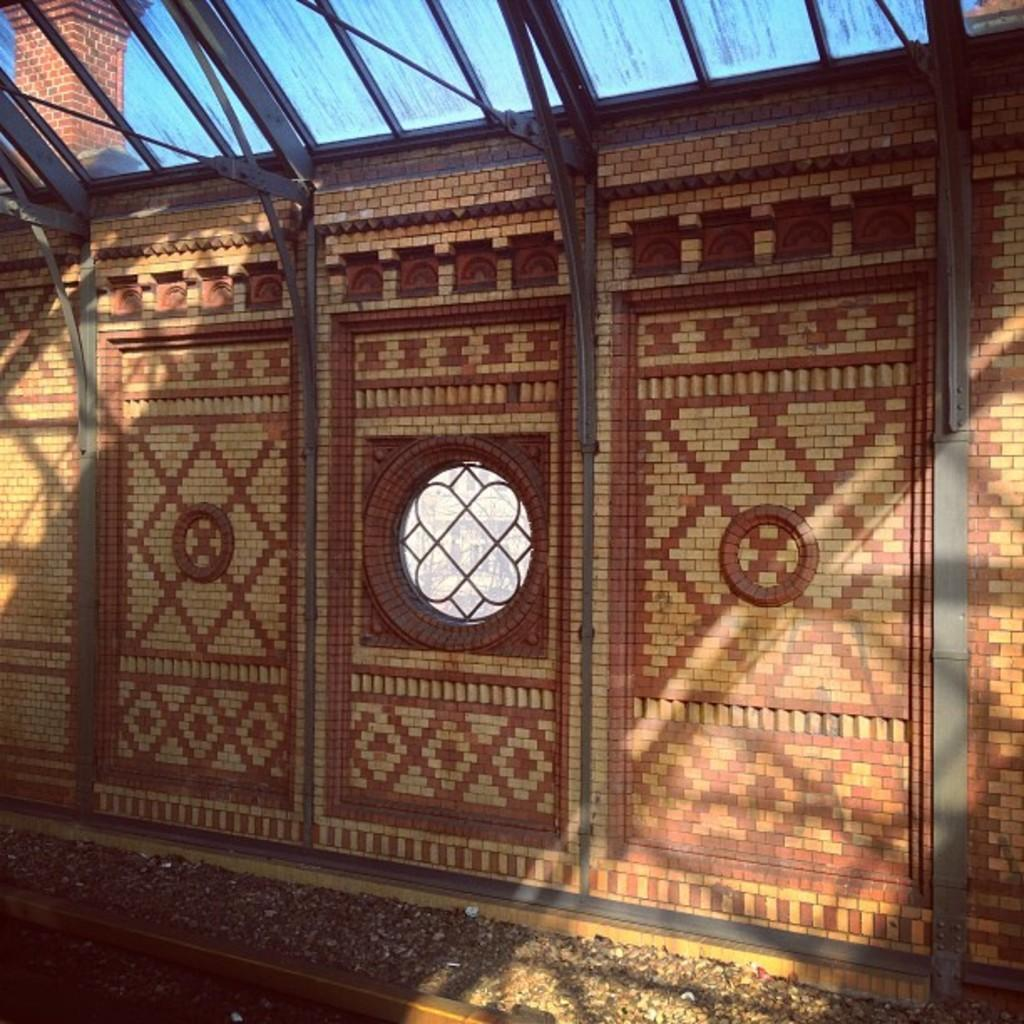What type of structure is present in the image? There is a wall in the image. Can you describe the color of the wall? The wall has a brown and cream color. What other feature can be seen in the image? There is a window in the image. How many eyes can be seen on the wall in the image? There are no eyes present on the wall in the image. 